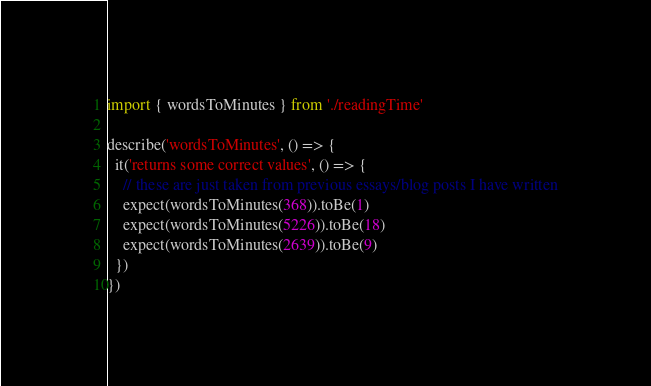<code> <loc_0><loc_0><loc_500><loc_500><_JavaScript_>import { wordsToMinutes } from './readingTime'

describe('wordsToMinutes', () => {
  it('returns some correct values', () => {
    // these are just taken from previous essays/blog posts I have written
    expect(wordsToMinutes(368)).toBe(1)
    expect(wordsToMinutes(5226)).toBe(18)
    expect(wordsToMinutes(2639)).toBe(9)
  })
})
</code> 